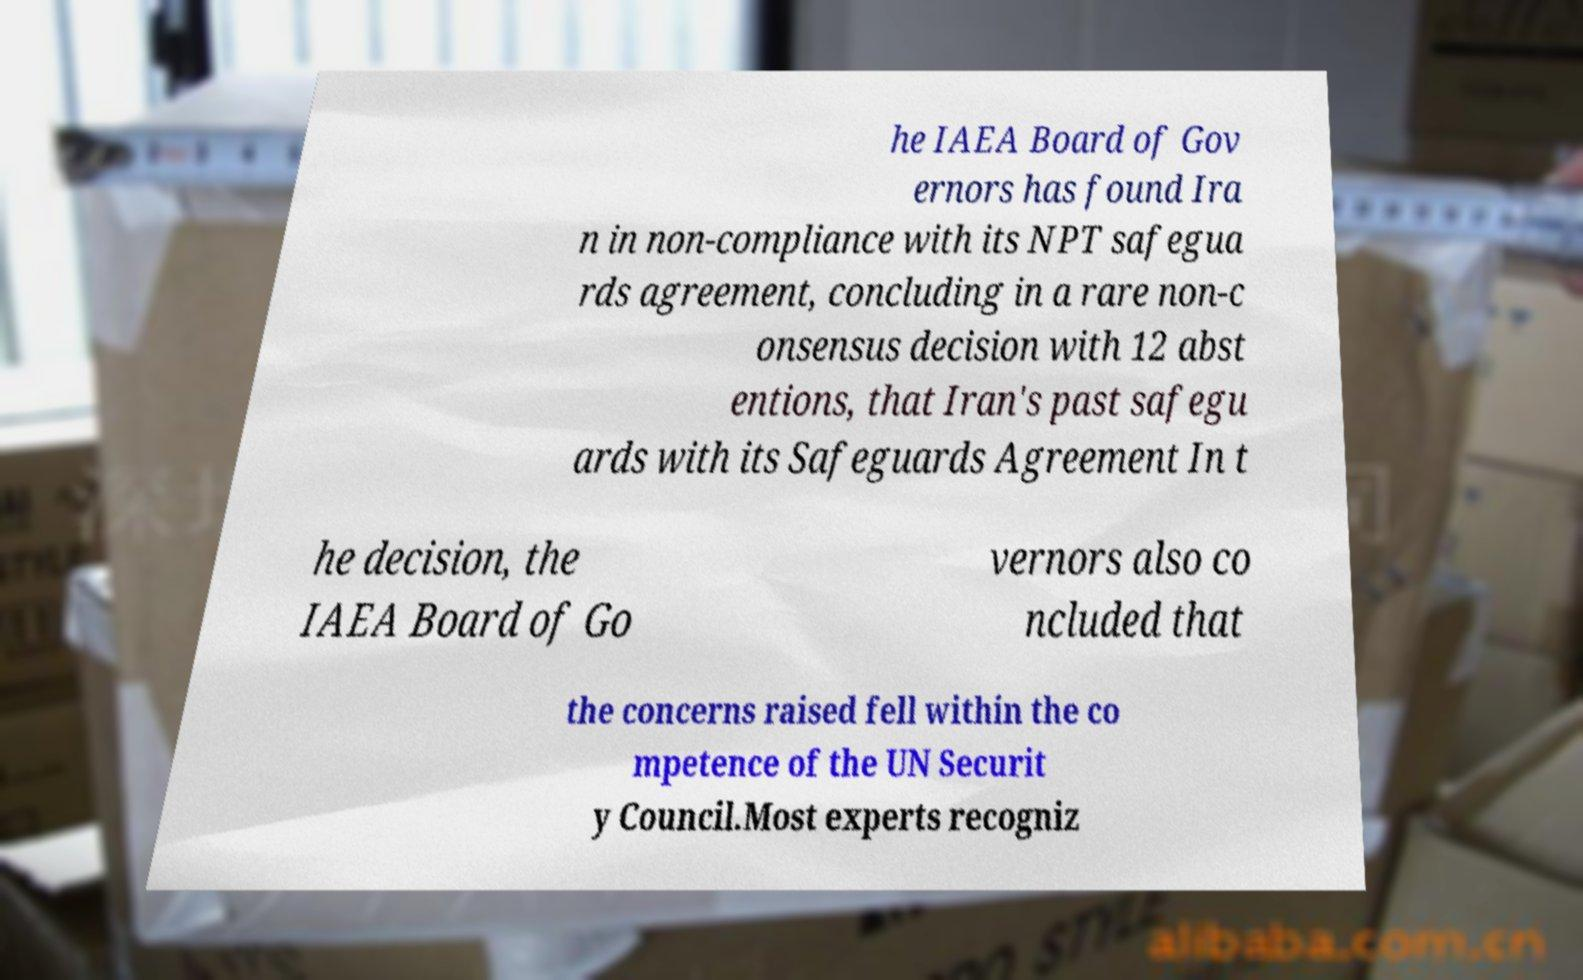I need the written content from this picture converted into text. Can you do that? he IAEA Board of Gov ernors has found Ira n in non-compliance with its NPT safegua rds agreement, concluding in a rare non-c onsensus decision with 12 abst entions, that Iran's past safegu ards with its Safeguards Agreement In t he decision, the IAEA Board of Go vernors also co ncluded that the concerns raised fell within the co mpetence of the UN Securit y Council.Most experts recogniz 